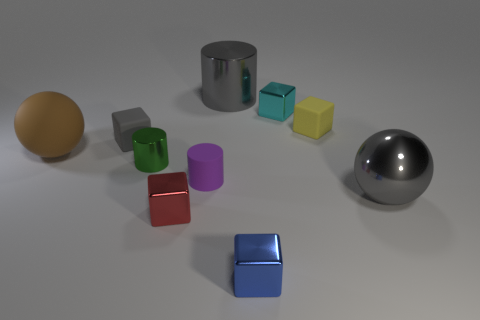How many tiny red matte spheres are there?
Offer a terse response. 0. There is a small metal thing that is behind the red cube and in front of the cyan block; what color is it?
Provide a succinct answer. Green. What size is the gray matte thing that is the same shape as the small yellow rubber object?
Provide a short and direct response. Small. What number of gray spheres have the same size as the green shiny cylinder?
Offer a terse response. 0. What is the material of the blue block?
Provide a succinct answer. Metal. Are there any tiny yellow matte blocks right of the small yellow rubber thing?
Offer a terse response. No. There is a purple thing that is made of the same material as the large brown sphere; what is its size?
Provide a succinct answer. Small. How many tiny cylinders are the same color as the big metal cylinder?
Give a very brief answer. 0. Are there fewer brown things that are on the right side of the small blue object than objects that are in front of the cyan metallic object?
Ensure brevity in your answer.  Yes. What is the size of the gray metallic thing that is behind the yellow rubber thing?
Your response must be concise. Large. 